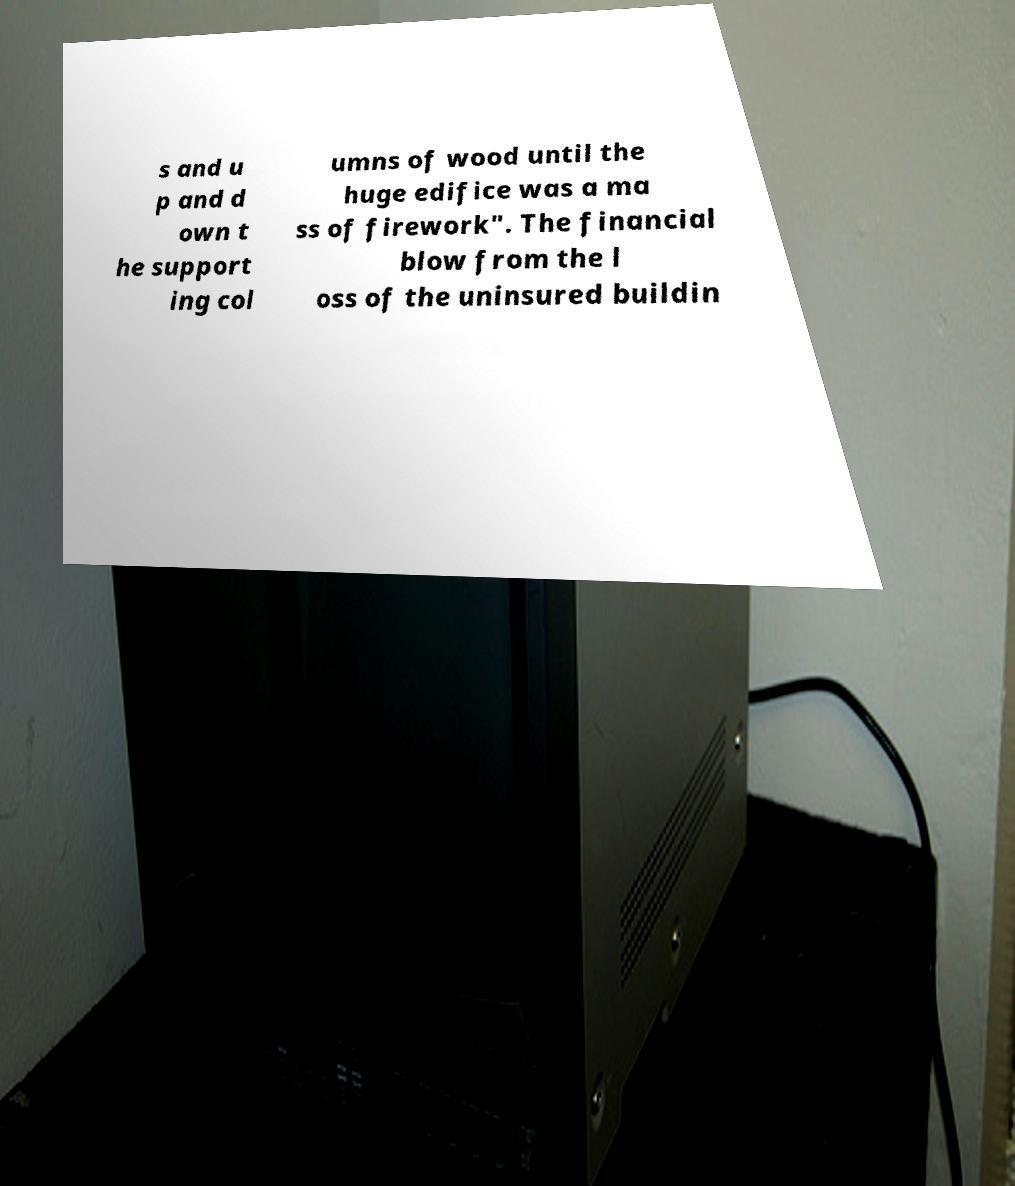Could you extract and type out the text from this image? s and u p and d own t he support ing col umns of wood until the huge edifice was a ma ss of firework". The financial blow from the l oss of the uninsured buildin 